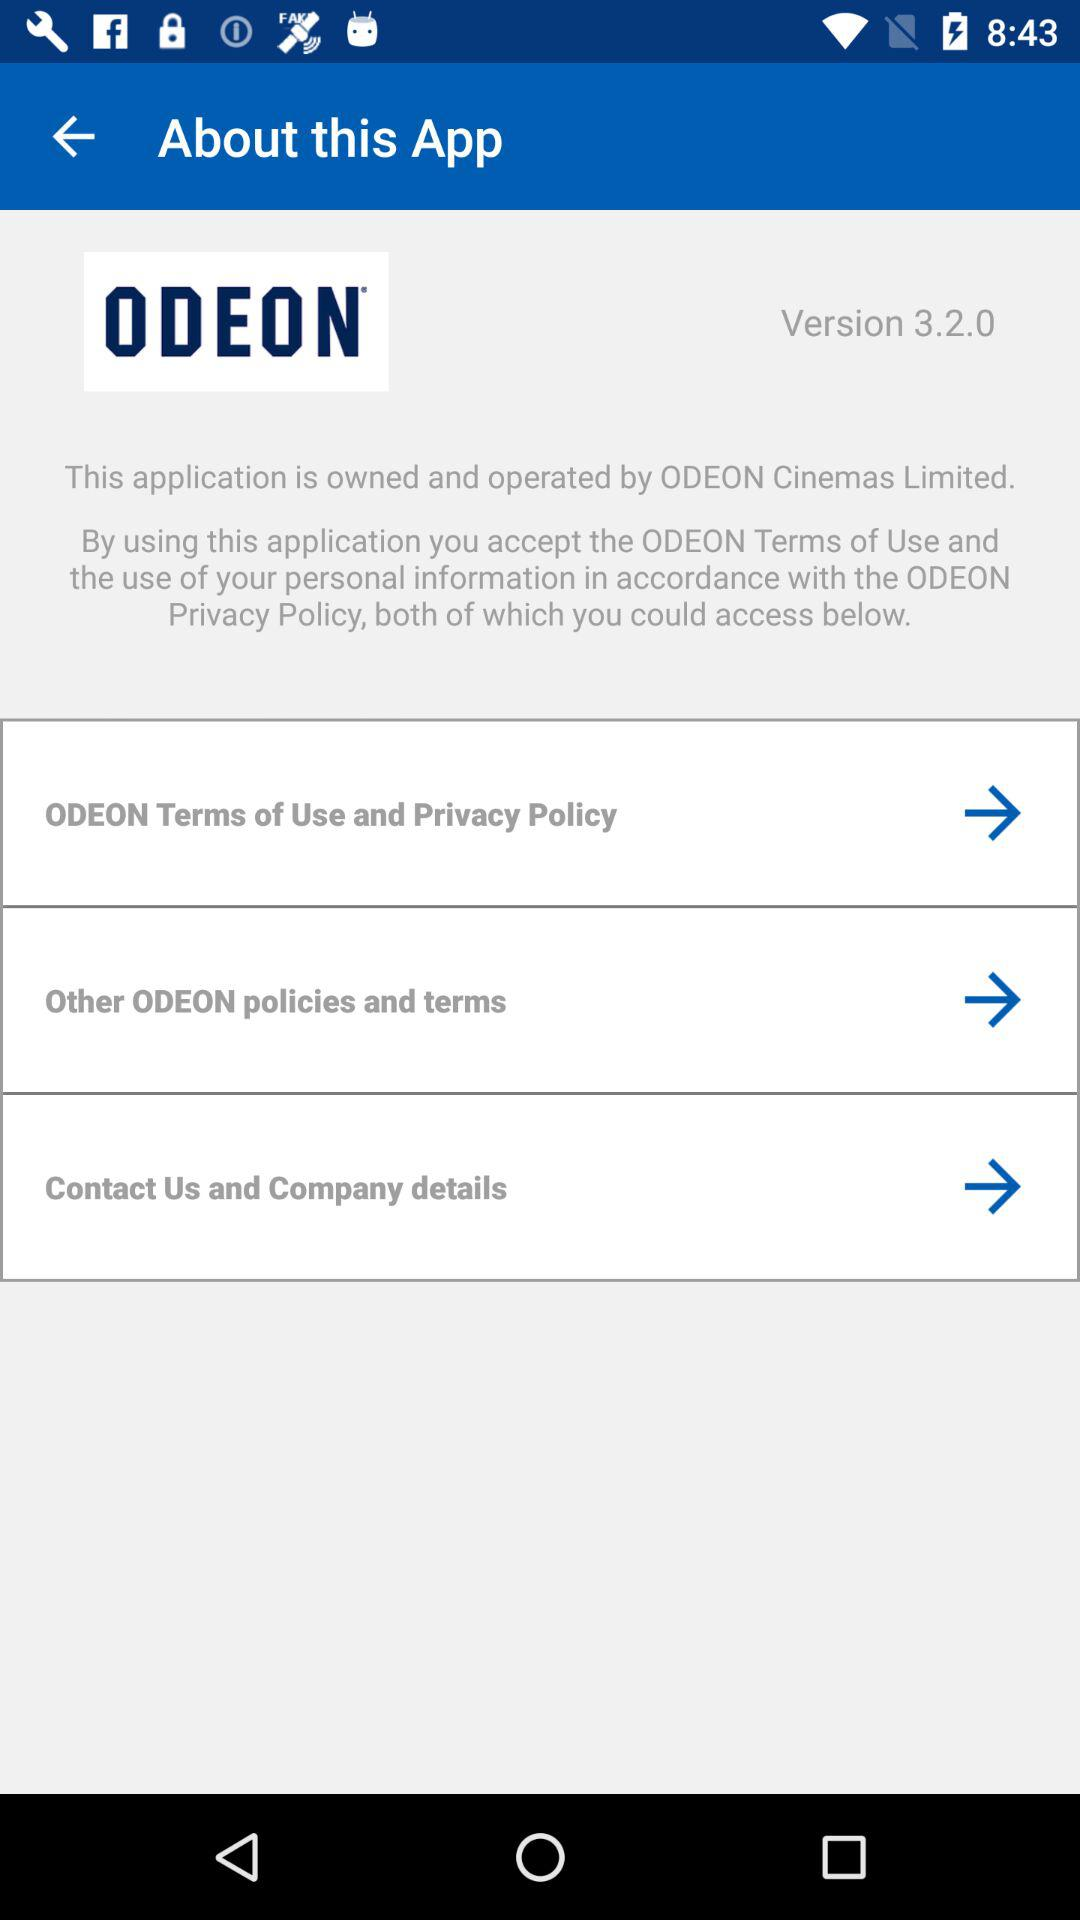What is the version? The version is 3.2.0. 